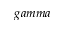<formula> <loc_0><loc_0><loc_500><loc_500>g a m m a</formula> 